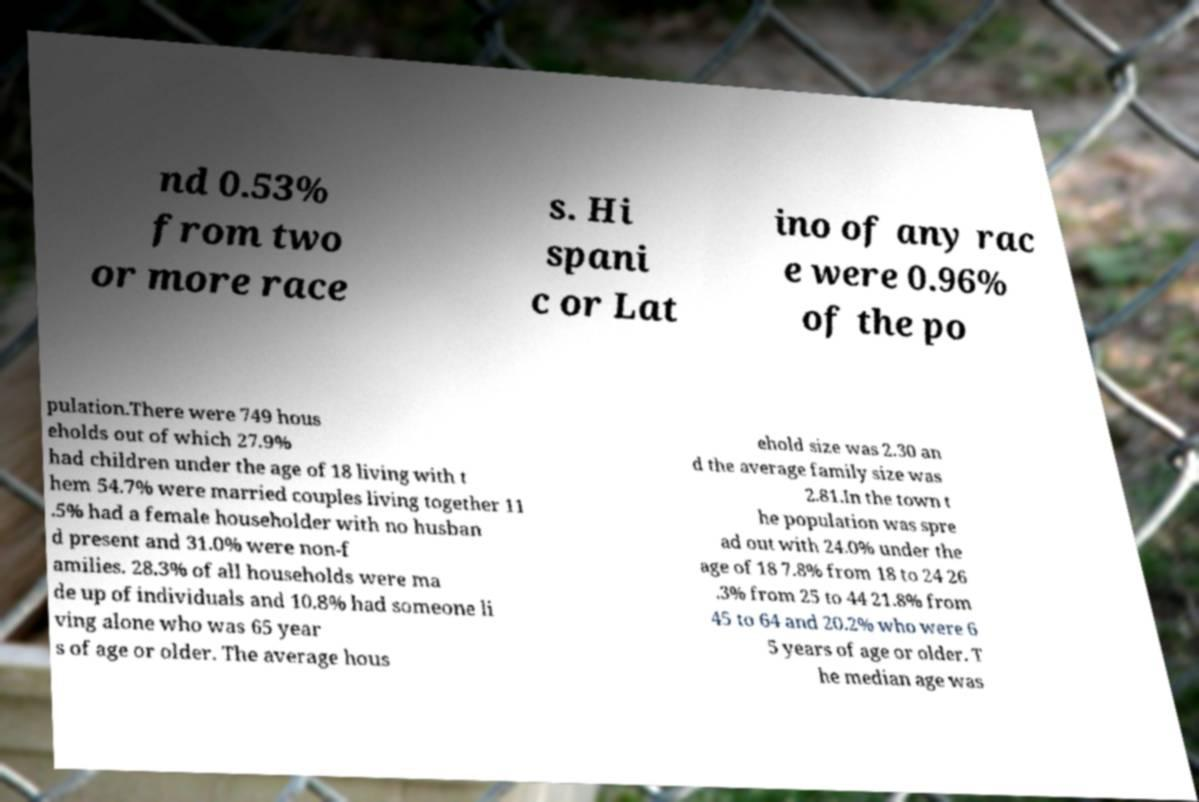What messages or text are displayed in this image? I need them in a readable, typed format. nd 0.53% from two or more race s. Hi spani c or Lat ino of any rac e were 0.96% of the po pulation.There were 749 hous eholds out of which 27.9% had children under the age of 18 living with t hem 54.7% were married couples living together 11 .5% had a female householder with no husban d present and 31.0% were non-f amilies. 28.3% of all households were ma de up of individuals and 10.8% had someone li ving alone who was 65 year s of age or older. The average hous ehold size was 2.30 an d the average family size was 2.81.In the town t he population was spre ad out with 24.0% under the age of 18 7.8% from 18 to 24 26 .3% from 25 to 44 21.8% from 45 to 64 and 20.2% who were 6 5 years of age or older. T he median age was 